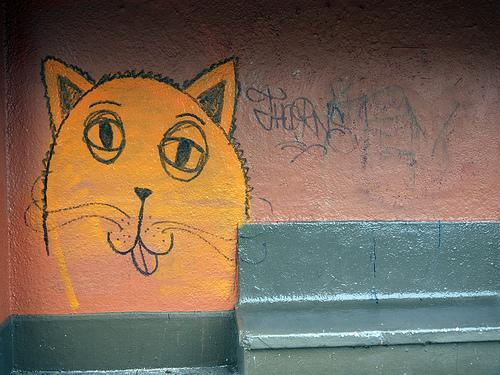Count the total number of big ships in the image. There are no big ships in the image. Describe the bench that is present in the image. There is no bench in the image. Describe the sentiment the image conveys. The image conveys a playful and simple artistic sentiment with a graffiti drawing of a cat on a wall. What is the color of the paint streak on the bench? There is no bench in the image, so there is no paint streak on a bench. Highlight the content of the graffiti in the image. The graffiti features a simple drawing of an orange cat with black outlines and details on a pinkish wall. Describe the interaction between the different objects in the image. The graffiti of the cat interacts with the plain wall by adding a touch of playful art to the otherwise unadorned surface. What is the object with the largest dimensions in the image? The object with the largest dimensions in the image is the wall itself. Identify any feline-related art in the graffiti. The feline-related art in the graffiti includes a simple drawing of an orange cat with black outlines. Give a brief overview of the entire image. The image features a simple graffiti drawing of an orange cat on a pinkish wall, adding a playful artistic touch to the scene. 